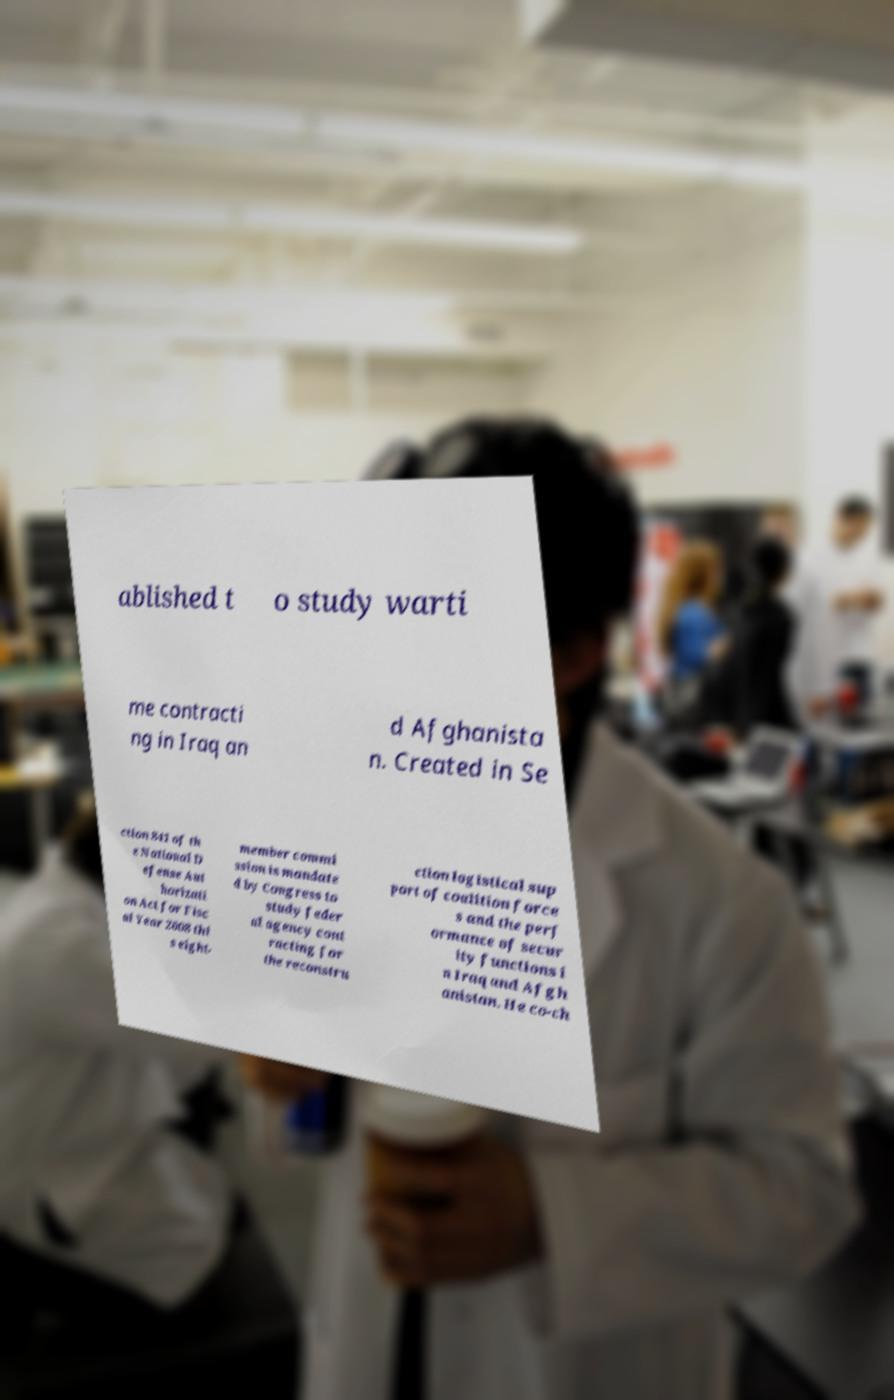Please read and relay the text visible in this image. What does it say? ablished t o study warti me contracti ng in Iraq an d Afghanista n. Created in Se ction 841 of th e National D efense Aut horizati on Act for Fisc al Year 2008 thi s eight- member commi ssion is mandate d by Congress to study feder al agency cont racting for the reconstru ction logistical sup port of coalition force s and the perf ormance of secur ity functions i n Iraq and Afgh anistan. He co-ch 